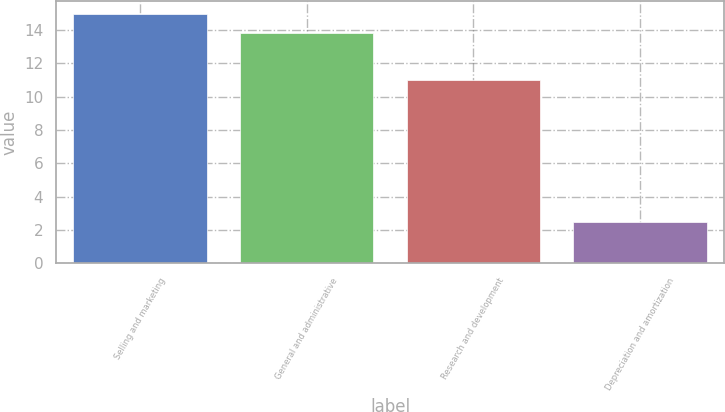<chart> <loc_0><loc_0><loc_500><loc_500><bar_chart><fcel>Selling and marketing<fcel>General and administrative<fcel>Research and development<fcel>Depreciation and amortization<nl><fcel>14.98<fcel>13.8<fcel>11<fcel>2.5<nl></chart> 